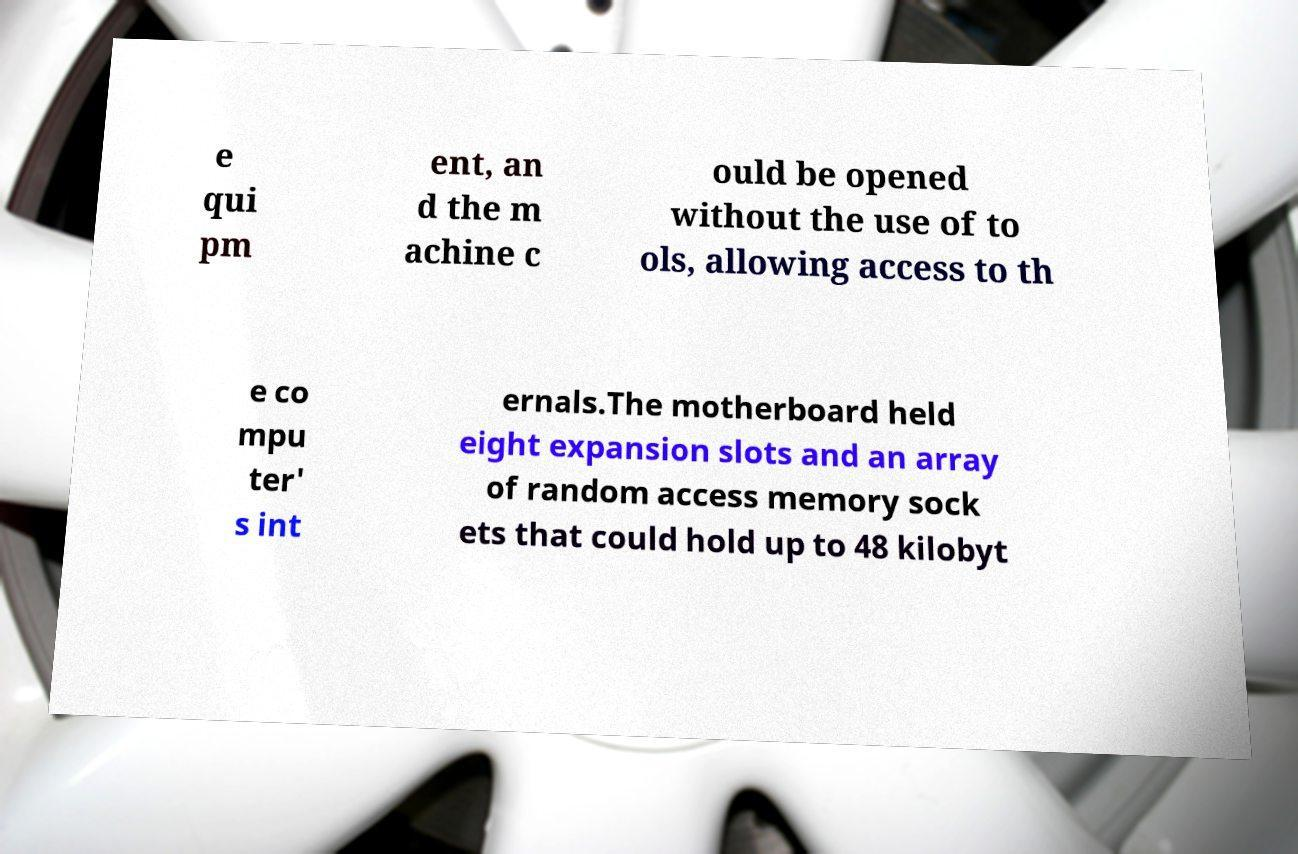I need the written content from this picture converted into text. Can you do that? e qui pm ent, an d the m achine c ould be opened without the use of to ols, allowing access to th e co mpu ter' s int ernals.The motherboard held eight expansion slots and an array of random access memory sock ets that could hold up to 48 kilobyt 